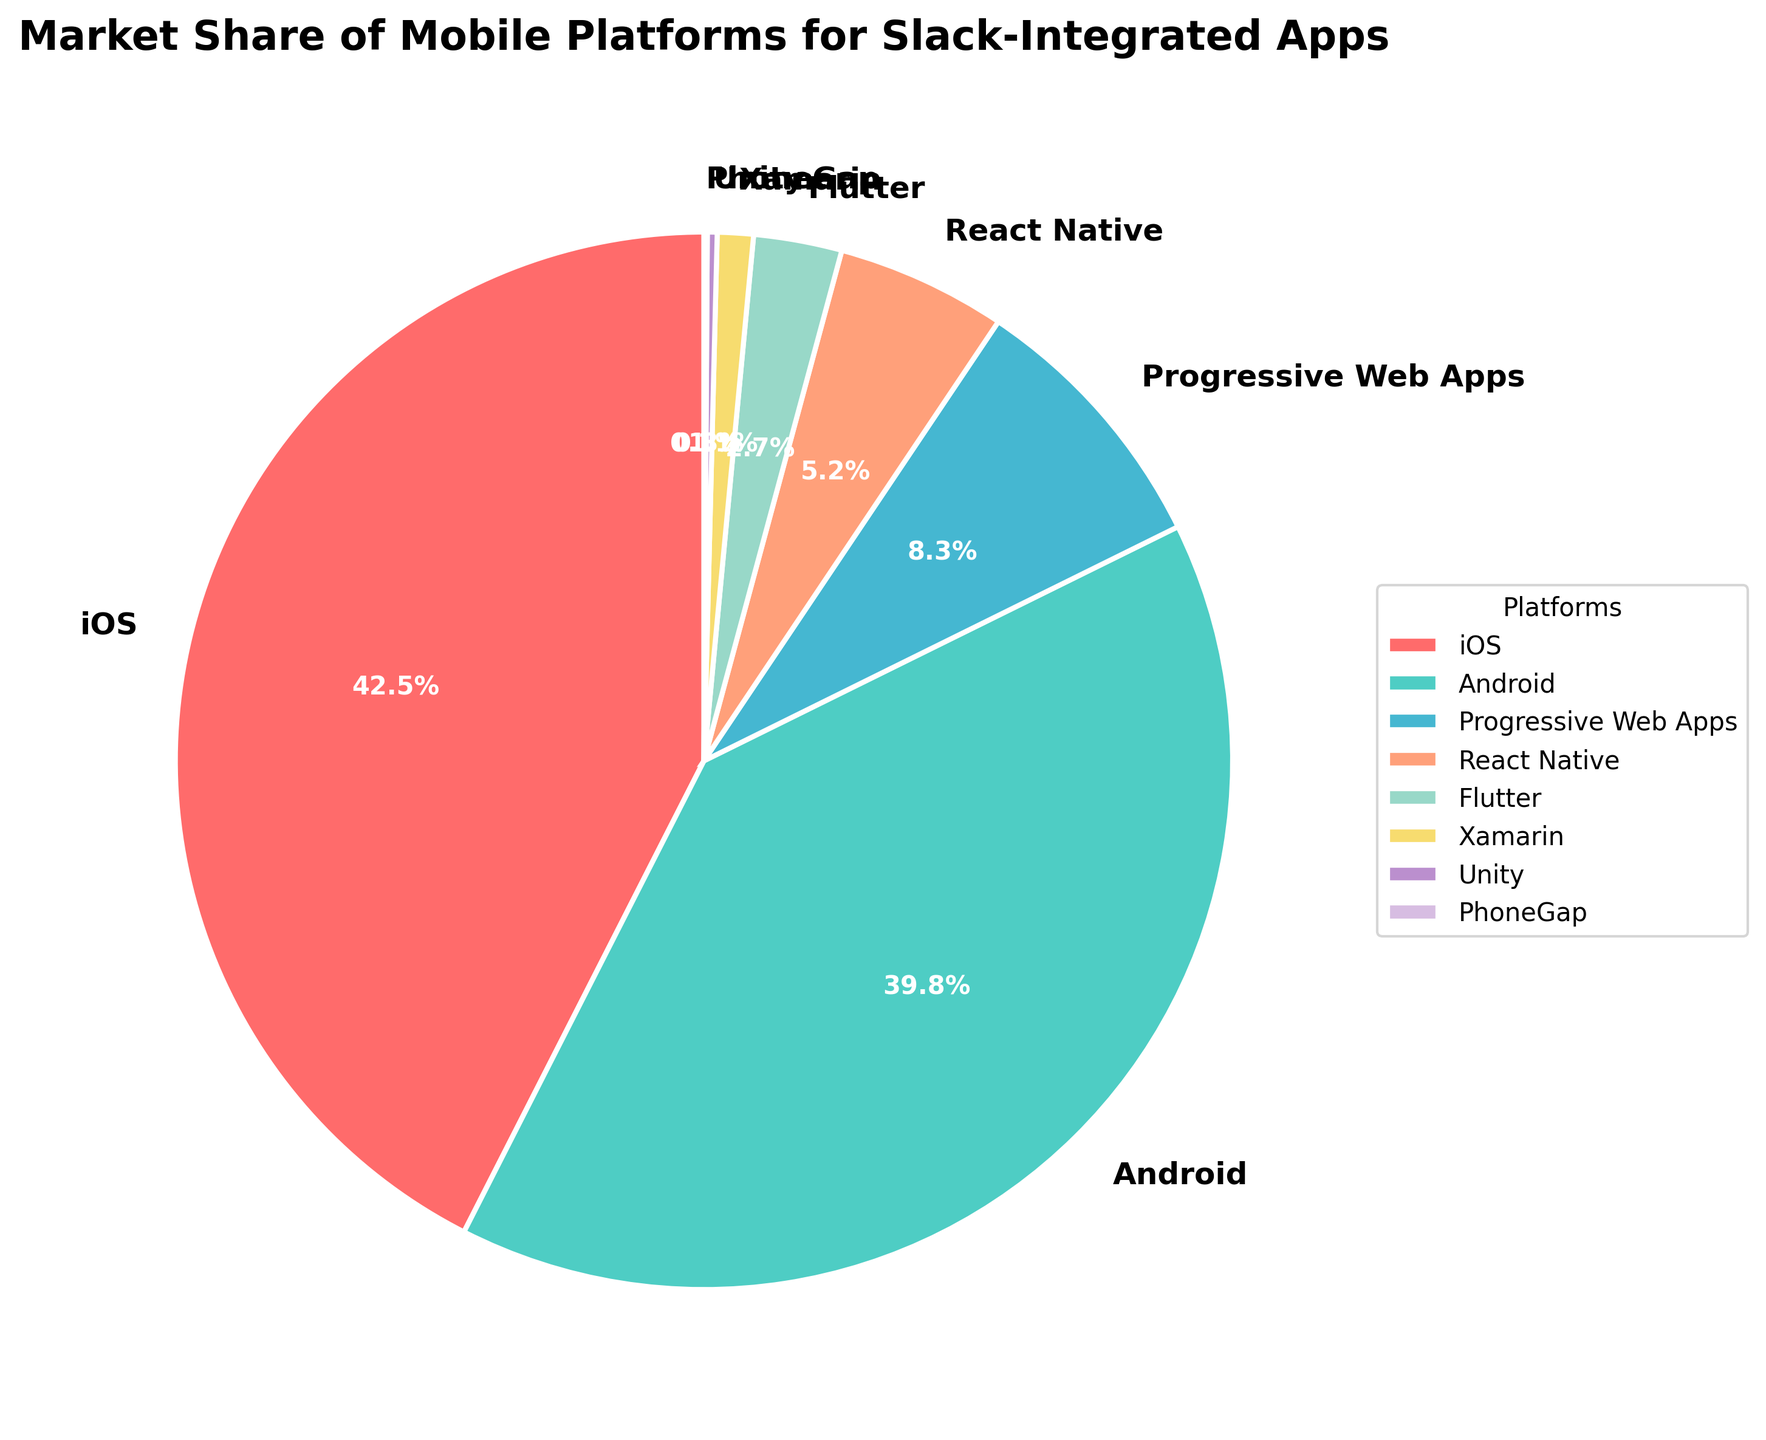Which platform has the highest market share? The platform with the highest market share can be identified by looking at the section of the pie chart that occupies the largest area. In this case, the largest section corresponds to iOS.
Answer: iOS What is the combined market share of Android and iOS? To find the combined market share, sum the individual shares of Android and iOS. Android has a market share of 39.8% and iOS has 42.5%. Thus, 39.8 + 42.5 = 82.3%.
Answer: 82.3% Which platform has the smallest market share? The platform with the smallest market share corresponds to the smallest slice of the pie chart. This would be PhoneGap.
Answer: PhoneGap How much larger is the market share of iOS compared to Progressive Web Apps? To find how much larger iOS's market share is compared to Progressive Web Apps, subtract the market share of Progressive Web Apps from iOS: 42.5% (iOS) - 8.3% (Progressive Web Apps) = 34.2%.
Answer: 34.2% Rank the platforms by market share from highest to lowest. To rank the platforms, list them from the one with the largest to the smallest pie chart segment. The order is iOS, Android, Progressive Web Apps, React Native, Flutter, Xamarin, Unity, PhoneGap.
Answer: iOS, Android, Progressive Web Apps, React Native, Flutter, Xamarin, Unity, PhoneGap What percentage of the market share is held by platforms other than iOS and Android? To find the market share held by platforms other than iOS and Android, sum the market shares of all platforms excluding iOS and Android. This is 8.3 + 5.2 + 2.7 + 1.1 + 0.3 + 0.1 = 17.7%.
Answer: 17.7% Are there any platforms that have a market share between 5% and 10%? If so, which ones? To find platforms within this range, look for slices of the pie chart that fall between 5% and 10%. The only platform in this range is Progressive Web Apps, which has a market share of 8.3%.
Answer: Progressive Web Apps Which two platforms have a combined market share closest to 10%? To find the two platforms whose combined market share is closest to 10%, sum the market shares of various pairs and see which sum is closest to 10%. React Native (5.2%) and Flutter (2.7%) sum up to 7.9%, while Xamarin (1.1%) and Unity (0.3%) sum up to 1.4%. 5.2% (React Native) + 2.7% (Flutter) = 7.9%, which is the closest to 10%.
Answer: React Native and Flutter What is the difference in market share between React Native and Flutter? To find the difference, subtract Flutter's market share from React Native's: 5.2% (React Native) - 2.7% (Flutter) = 2.5%.
Answer: 2.5% 